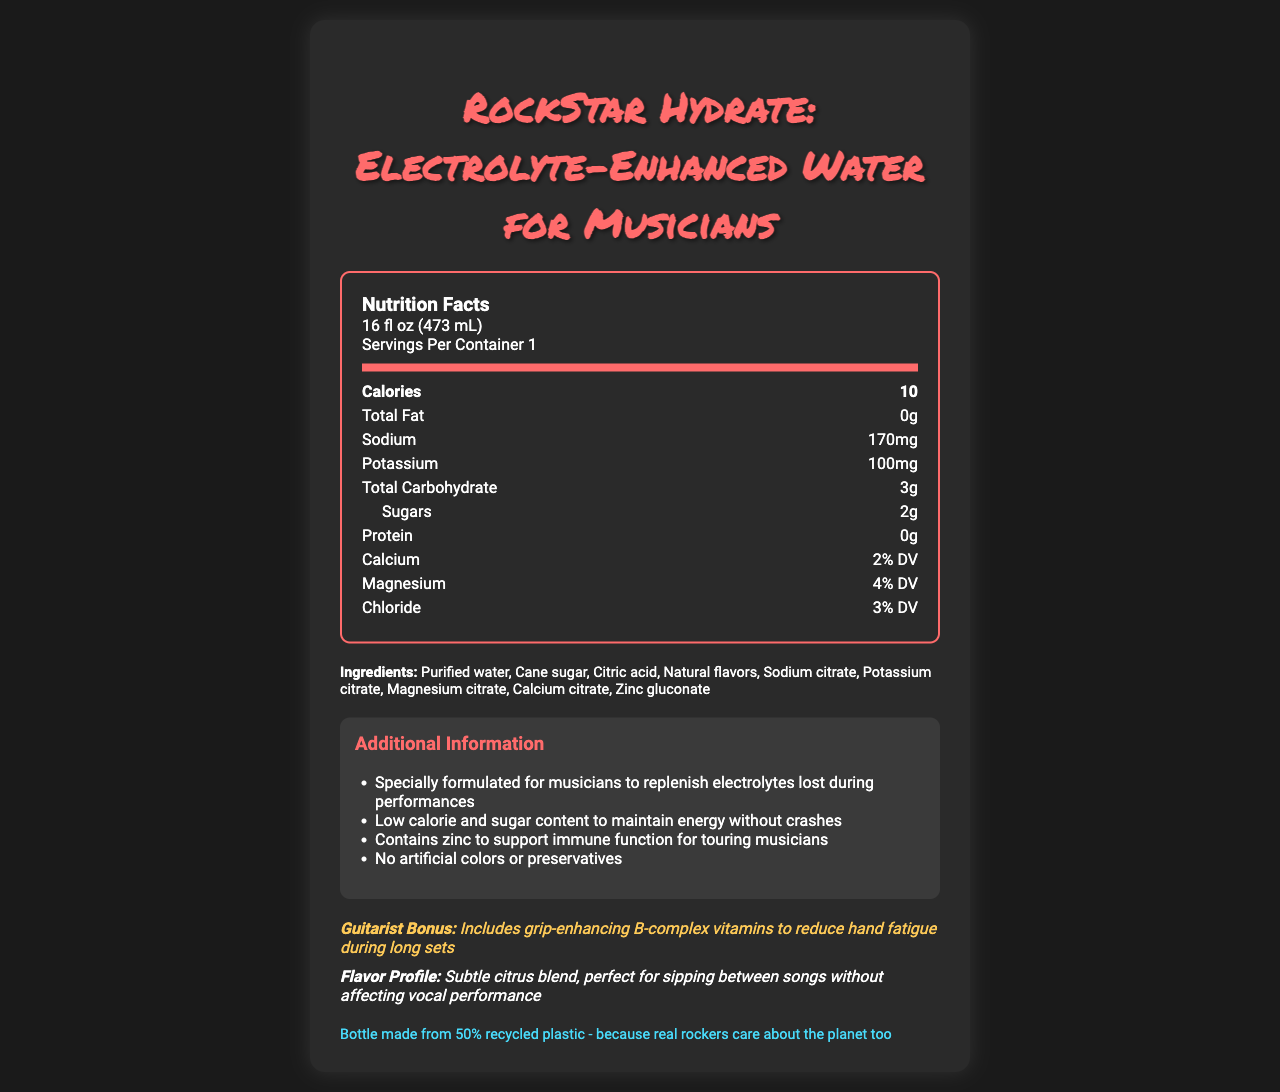how many calories are in a serving? The document states that there are 10 calories per serving.
Answer: 10 what is the serving size for this product? The serving size is indicated as 16 fl oz, or 473 mL.
Answer: 16 fl oz (473 mL) which ingredient is listed first? Ingredients are listed in order of predominance, with purified water being the first ingredient mentioned.
Answer: Purified water what is the main flavor profile of the drink? The document describes the flavor profile as a subtle citrus blend.
Answer: Subtle citrus blend how much sodium is in a serving? The amount of sodium per serving is listed as 170mg.
Answer: 170mg what additional benefit does the drink provide for guitarists? The document mentions that the drink includes grip-enhancing B-complex vitamins to reduce hand fatigue during long sets.
Answer: Reduces hand fatigue during long sets through grip-enhancing B-complex vitamins what percentage of the daily value of calcium does the drink provide? The document indicates that the calcium content is 2% of the daily value.
Answer: 2% DV how many grams of sugars are in this drink? The document states that the drink contains 2 grams of sugars per serving.
Answer: 2g does this drink contain any artificial colors or preservatives? The document specifies that it contains no artificial colors or preservatives.
Answer: No Which mineral supports immune function for touring musicians? A. Calcium B. Magnesium C. Zinc D. Potassium The additional information section mentions that zinc is included to support immune function for touring musicians.
Answer: C. Zinc how many servings are there per container? The document indicates that there is 1 serving per container.
Answer: 1 which of the following is a key benefit of the drink, aside from hydration? A. Supports bone health B. Enhances vocal performance C. Supports immune function D. Reduces muscle soreness The additional information section mentions zinc is included to support immune function.
Answer: C. Supports immune function what is the total carbohydrate content per serving? The document lists the total carbohydrate content as 3 grams per serving.
Answer: 3g Is the bottle made from recycled plastic? The sustainability note section states that the bottle is made from 50% recycled plastic.
Answer: Yes what is the daily value percentage of magnesium in the drink? The document states that the drink provides 4% of the daily value for magnesium.
Answer: 4% DV summarize the main idea of the document. The document is focused on presenting the nutritional content and benefits of RockStar Hydrate, emphasizing its formulation for musicians and its environmentally-friendly packaging.
Answer: The document provides nutrition facts for "RockStar Hydrate: Electrolyte-Enhanced Water for Musicians," which is designed to replenish electrolytes lost during performances, maintain energy levels, and support immune function. The drink is low in calories and sugar and includes grip-enhancing B-complex vitamins for guitarists, contains no artificial colors or preservatives, and is packaged in a bottle made from 50% recycled plastic. how much chloride does the drink contain? The document indicates that the chloride content is 3% of the daily value.
Answer: 3% DV what is the company’s policy regarding artificial ingredients? The document states that there are no artificial colors or preservatives in the drink, but it does not provide a comprehensive company policy on artificial ingredients.
Answer: Not stated 